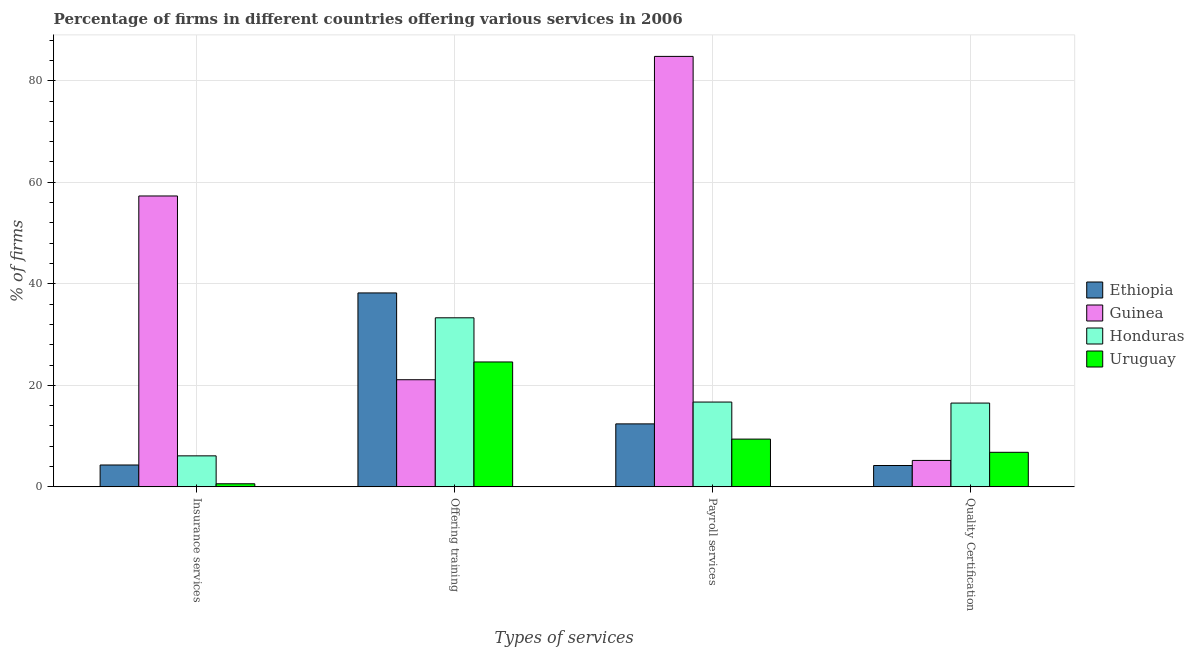How many different coloured bars are there?
Your answer should be very brief. 4. How many groups of bars are there?
Provide a succinct answer. 4. How many bars are there on the 2nd tick from the left?
Your answer should be very brief. 4. What is the label of the 4th group of bars from the left?
Provide a succinct answer. Quality Certification. Across all countries, what is the maximum percentage of firms offering insurance services?
Your answer should be very brief. 57.3. Across all countries, what is the minimum percentage of firms offering quality certification?
Offer a very short reply. 4.2. In which country was the percentage of firms offering insurance services maximum?
Make the answer very short. Guinea. In which country was the percentage of firms offering training minimum?
Offer a terse response. Guinea. What is the total percentage of firms offering insurance services in the graph?
Offer a very short reply. 68.3. What is the difference between the percentage of firms offering payroll services in Guinea and that in Honduras?
Make the answer very short. 68.1. What is the difference between the percentage of firms offering quality certification in Ethiopia and the percentage of firms offering training in Honduras?
Keep it short and to the point. -29.1. What is the average percentage of firms offering quality certification per country?
Ensure brevity in your answer.  8.17. What is the difference between the percentage of firms offering quality certification and percentage of firms offering payroll services in Uruguay?
Your response must be concise. -2.6. In how many countries, is the percentage of firms offering payroll services greater than 4 %?
Offer a very short reply. 4. What is the ratio of the percentage of firms offering quality certification in Honduras to that in Uruguay?
Offer a very short reply. 2.43. Is the difference between the percentage of firms offering payroll services in Ethiopia and Guinea greater than the difference between the percentage of firms offering quality certification in Ethiopia and Guinea?
Make the answer very short. No. What is the difference between the highest and the second highest percentage of firms offering payroll services?
Your answer should be very brief. 68.1. What is the difference between the highest and the lowest percentage of firms offering insurance services?
Provide a short and direct response. 56.7. Is the sum of the percentage of firms offering insurance services in Ethiopia and Honduras greater than the maximum percentage of firms offering quality certification across all countries?
Give a very brief answer. No. Is it the case that in every country, the sum of the percentage of firms offering payroll services and percentage of firms offering training is greater than the sum of percentage of firms offering quality certification and percentage of firms offering insurance services?
Your answer should be compact. Yes. What does the 4th bar from the left in Quality Certification represents?
Your response must be concise. Uruguay. What does the 4th bar from the right in Quality Certification represents?
Your answer should be compact. Ethiopia. Are all the bars in the graph horizontal?
Provide a succinct answer. No. Where does the legend appear in the graph?
Your response must be concise. Center right. How are the legend labels stacked?
Provide a short and direct response. Vertical. What is the title of the graph?
Provide a succinct answer. Percentage of firms in different countries offering various services in 2006. Does "Lithuania" appear as one of the legend labels in the graph?
Your response must be concise. No. What is the label or title of the X-axis?
Keep it short and to the point. Types of services. What is the label or title of the Y-axis?
Keep it short and to the point. % of firms. What is the % of firms in Guinea in Insurance services?
Provide a succinct answer. 57.3. What is the % of firms in Honduras in Insurance services?
Your answer should be very brief. 6.1. What is the % of firms in Ethiopia in Offering training?
Your response must be concise. 38.2. What is the % of firms of Guinea in Offering training?
Offer a very short reply. 21.1. What is the % of firms in Honduras in Offering training?
Give a very brief answer. 33.3. What is the % of firms in Uruguay in Offering training?
Offer a very short reply. 24.6. What is the % of firms in Ethiopia in Payroll services?
Provide a succinct answer. 12.4. What is the % of firms in Guinea in Payroll services?
Ensure brevity in your answer.  84.8. What is the % of firms in Honduras in Payroll services?
Ensure brevity in your answer.  16.7. What is the % of firms in Uruguay in Payroll services?
Offer a terse response. 9.4. What is the % of firms of Guinea in Quality Certification?
Make the answer very short. 5.2. What is the % of firms of Uruguay in Quality Certification?
Your response must be concise. 6.8. Across all Types of services, what is the maximum % of firms in Ethiopia?
Your answer should be compact. 38.2. Across all Types of services, what is the maximum % of firms in Guinea?
Your answer should be very brief. 84.8. Across all Types of services, what is the maximum % of firms of Honduras?
Provide a short and direct response. 33.3. Across all Types of services, what is the maximum % of firms in Uruguay?
Your response must be concise. 24.6. Across all Types of services, what is the minimum % of firms in Ethiopia?
Offer a terse response. 4.2. Across all Types of services, what is the minimum % of firms of Guinea?
Your answer should be compact. 5.2. Across all Types of services, what is the minimum % of firms of Uruguay?
Your answer should be very brief. 0.6. What is the total % of firms of Ethiopia in the graph?
Make the answer very short. 59.1. What is the total % of firms in Guinea in the graph?
Your response must be concise. 168.4. What is the total % of firms in Honduras in the graph?
Your answer should be very brief. 72.6. What is the total % of firms in Uruguay in the graph?
Offer a terse response. 41.4. What is the difference between the % of firms of Ethiopia in Insurance services and that in Offering training?
Your answer should be compact. -33.9. What is the difference between the % of firms in Guinea in Insurance services and that in Offering training?
Provide a short and direct response. 36.2. What is the difference between the % of firms in Honduras in Insurance services and that in Offering training?
Make the answer very short. -27.2. What is the difference between the % of firms in Uruguay in Insurance services and that in Offering training?
Your response must be concise. -24. What is the difference between the % of firms of Ethiopia in Insurance services and that in Payroll services?
Offer a very short reply. -8.1. What is the difference between the % of firms of Guinea in Insurance services and that in Payroll services?
Your response must be concise. -27.5. What is the difference between the % of firms in Honduras in Insurance services and that in Payroll services?
Offer a very short reply. -10.6. What is the difference between the % of firms in Uruguay in Insurance services and that in Payroll services?
Keep it short and to the point. -8.8. What is the difference between the % of firms of Guinea in Insurance services and that in Quality Certification?
Your answer should be compact. 52.1. What is the difference between the % of firms of Honduras in Insurance services and that in Quality Certification?
Provide a short and direct response. -10.4. What is the difference between the % of firms in Ethiopia in Offering training and that in Payroll services?
Provide a succinct answer. 25.8. What is the difference between the % of firms in Guinea in Offering training and that in Payroll services?
Give a very brief answer. -63.7. What is the difference between the % of firms of Honduras in Offering training and that in Payroll services?
Your answer should be compact. 16.6. What is the difference between the % of firms in Uruguay in Offering training and that in Payroll services?
Provide a succinct answer. 15.2. What is the difference between the % of firms in Ethiopia in Offering training and that in Quality Certification?
Offer a very short reply. 34. What is the difference between the % of firms in Uruguay in Offering training and that in Quality Certification?
Ensure brevity in your answer.  17.8. What is the difference between the % of firms of Guinea in Payroll services and that in Quality Certification?
Your answer should be compact. 79.6. What is the difference between the % of firms of Uruguay in Payroll services and that in Quality Certification?
Keep it short and to the point. 2.6. What is the difference between the % of firms in Ethiopia in Insurance services and the % of firms in Guinea in Offering training?
Provide a short and direct response. -16.8. What is the difference between the % of firms in Ethiopia in Insurance services and the % of firms in Honduras in Offering training?
Your answer should be very brief. -29. What is the difference between the % of firms in Ethiopia in Insurance services and the % of firms in Uruguay in Offering training?
Provide a succinct answer. -20.3. What is the difference between the % of firms in Guinea in Insurance services and the % of firms in Uruguay in Offering training?
Provide a short and direct response. 32.7. What is the difference between the % of firms of Honduras in Insurance services and the % of firms of Uruguay in Offering training?
Your response must be concise. -18.5. What is the difference between the % of firms in Ethiopia in Insurance services and the % of firms in Guinea in Payroll services?
Your response must be concise. -80.5. What is the difference between the % of firms in Ethiopia in Insurance services and the % of firms in Uruguay in Payroll services?
Offer a terse response. -5.1. What is the difference between the % of firms in Guinea in Insurance services and the % of firms in Honduras in Payroll services?
Provide a short and direct response. 40.6. What is the difference between the % of firms of Guinea in Insurance services and the % of firms of Uruguay in Payroll services?
Provide a short and direct response. 47.9. What is the difference between the % of firms in Honduras in Insurance services and the % of firms in Uruguay in Payroll services?
Offer a terse response. -3.3. What is the difference between the % of firms in Guinea in Insurance services and the % of firms in Honduras in Quality Certification?
Offer a terse response. 40.8. What is the difference between the % of firms in Guinea in Insurance services and the % of firms in Uruguay in Quality Certification?
Offer a very short reply. 50.5. What is the difference between the % of firms in Ethiopia in Offering training and the % of firms in Guinea in Payroll services?
Ensure brevity in your answer.  -46.6. What is the difference between the % of firms in Ethiopia in Offering training and the % of firms in Honduras in Payroll services?
Make the answer very short. 21.5. What is the difference between the % of firms in Ethiopia in Offering training and the % of firms in Uruguay in Payroll services?
Provide a short and direct response. 28.8. What is the difference between the % of firms of Guinea in Offering training and the % of firms of Honduras in Payroll services?
Give a very brief answer. 4.4. What is the difference between the % of firms of Honduras in Offering training and the % of firms of Uruguay in Payroll services?
Provide a succinct answer. 23.9. What is the difference between the % of firms in Ethiopia in Offering training and the % of firms in Guinea in Quality Certification?
Provide a short and direct response. 33. What is the difference between the % of firms in Ethiopia in Offering training and the % of firms in Honduras in Quality Certification?
Make the answer very short. 21.7. What is the difference between the % of firms of Ethiopia in Offering training and the % of firms of Uruguay in Quality Certification?
Provide a succinct answer. 31.4. What is the difference between the % of firms of Honduras in Offering training and the % of firms of Uruguay in Quality Certification?
Provide a succinct answer. 26.5. What is the difference between the % of firms in Guinea in Payroll services and the % of firms in Honduras in Quality Certification?
Provide a short and direct response. 68.3. What is the difference between the % of firms of Honduras in Payroll services and the % of firms of Uruguay in Quality Certification?
Your response must be concise. 9.9. What is the average % of firms in Ethiopia per Types of services?
Keep it short and to the point. 14.78. What is the average % of firms of Guinea per Types of services?
Make the answer very short. 42.1. What is the average % of firms in Honduras per Types of services?
Ensure brevity in your answer.  18.15. What is the average % of firms of Uruguay per Types of services?
Offer a very short reply. 10.35. What is the difference between the % of firms in Ethiopia and % of firms in Guinea in Insurance services?
Your answer should be compact. -53. What is the difference between the % of firms in Ethiopia and % of firms in Honduras in Insurance services?
Your answer should be compact. -1.8. What is the difference between the % of firms in Ethiopia and % of firms in Uruguay in Insurance services?
Keep it short and to the point. 3.7. What is the difference between the % of firms in Guinea and % of firms in Honduras in Insurance services?
Make the answer very short. 51.2. What is the difference between the % of firms of Guinea and % of firms of Uruguay in Insurance services?
Offer a very short reply. 56.7. What is the difference between the % of firms in Honduras and % of firms in Uruguay in Insurance services?
Ensure brevity in your answer.  5.5. What is the difference between the % of firms of Ethiopia and % of firms of Uruguay in Offering training?
Make the answer very short. 13.6. What is the difference between the % of firms of Guinea and % of firms of Honduras in Offering training?
Ensure brevity in your answer.  -12.2. What is the difference between the % of firms in Guinea and % of firms in Uruguay in Offering training?
Offer a terse response. -3.5. What is the difference between the % of firms in Honduras and % of firms in Uruguay in Offering training?
Your answer should be compact. 8.7. What is the difference between the % of firms in Ethiopia and % of firms in Guinea in Payroll services?
Make the answer very short. -72.4. What is the difference between the % of firms in Guinea and % of firms in Honduras in Payroll services?
Your answer should be very brief. 68.1. What is the difference between the % of firms of Guinea and % of firms of Uruguay in Payroll services?
Give a very brief answer. 75.4. What is the difference between the % of firms of Honduras and % of firms of Uruguay in Payroll services?
Offer a terse response. 7.3. What is the difference between the % of firms in Ethiopia and % of firms in Guinea in Quality Certification?
Your response must be concise. -1. What is the difference between the % of firms of Guinea and % of firms of Honduras in Quality Certification?
Provide a short and direct response. -11.3. What is the ratio of the % of firms of Ethiopia in Insurance services to that in Offering training?
Make the answer very short. 0.11. What is the ratio of the % of firms in Guinea in Insurance services to that in Offering training?
Offer a very short reply. 2.72. What is the ratio of the % of firms of Honduras in Insurance services to that in Offering training?
Keep it short and to the point. 0.18. What is the ratio of the % of firms in Uruguay in Insurance services to that in Offering training?
Keep it short and to the point. 0.02. What is the ratio of the % of firms of Ethiopia in Insurance services to that in Payroll services?
Offer a terse response. 0.35. What is the ratio of the % of firms of Guinea in Insurance services to that in Payroll services?
Offer a terse response. 0.68. What is the ratio of the % of firms of Honduras in Insurance services to that in Payroll services?
Provide a short and direct response. 0.37. What is the ratio of the % of firms of Uruguay in Insurance services to that in Payroll services?
Your answer should be very brief. 0.06. What is the ratio of the % of firms of Ethiopia in Insurance services to that in Quality Certification?
Offer a terse response. 1.02. What is the ratio of the % of firms in Guinea in Insurance services to that in Quality Certification?
Offer a terse response. 11.02. What is the ratio of the % of firms in Honduras in Insurance services to that in Quality Certification?
Your answer should be very brief. 0.37. What is the ratio of the % of firms of Uruguay in Insurance services to that in Quality Certification?
Your answer should be very brief. 0.09. What is the ratio of the % of firms in Ethiopia in Offering training to that in Payroll services?
Your answer should be very brief. 3.08. What is the ratio of the % of firms in Guinea in Offering training to that in Payroll services?
Your answer should be very brief. 0.25. What is the ratio of the % of firms in Honduras in Offering training to that in Payroll services?
Keep it short and to the point. 1.99. What is the ratio of the % of firms of Uruguay in Offering training to that in Payroll services?
Your response must be concise. 2.62. What is the ratio of the % of firms of Ethiopia in Offering training to that in Quality Certification?
Your answer should be compact. 9.1. What is the ratio of the % of firms of Guinea in Offering training to that in Quality Certification?
Your answer should be very brief. 4.06. What is the ratio of the % of firms in Honduras in Offering training to that in Quality Certification?
Your answer should be very brief. 2.02. What is the ratio of the % of firms in Uruguay in Offering training to that in Quality Certification?
Provide a short and direct response. 3.62. What is the ratio of the % of firms in Ethiopia in Payroll services to that in Quality Certification?
Make the answer very short. 2.95. What is the ratio of the % of firms in Guinea in Payroll services to that in Quality Certification?
Provide a short and direct response. 16.31. What is the ratio of the % of firms of Honduras in Payroll services to that in Quality Certification?
Your answer should be compact. 1.01. What is the ratio of the % of firms in Uruguay in Payroll services to that in Quality Certification?
Make the answer very short. 1.38. What is the difference between the highest and the second highest % of firms in Ethiopia?
Provide a succinct answer. 25.8. What is the difference between the highest and the second highest % of firms of Guinea?
Provide a short and direct response. 27.5. What is the difference between the highest and the second highest % of firms of Honduras?
Offer a very short reply. 16.6. What is the difference between the highest and the lowest % of firms of Ethiopia?
Offer a terse response. 34. What is the difference between the highest and the lowest % of firms of Guinea?
Provide a succinct answer. 79.6. What is the difference between the highest and the lowest % of firms in Honduras?
Ensure brevity in your answer.  27.2. What is the difference between the highest and the lowest % of firms in Uruguay?
Keep it short and to the point. 24. 